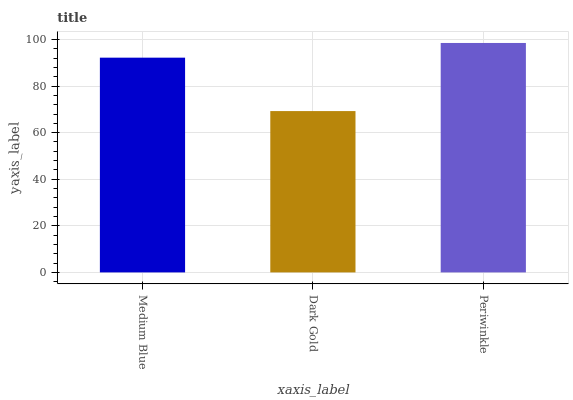Is Periwinkle the minimum?
Answer yes or no. No. Is Dark Gold the maximum?
Answer yes or no. No. Is Periwinkle greater than Dark Gold?
Answer yes or no. Yes. Is Dark Gold less than Periwinkle?
Answer yes or no. Yes. Is Dark Gold greater than Periwinkle?
Answer yes or no. No. Is Periwinkle less than Dark Gold?
Answer yes or no. No. Is Medium Blue the high median?
Answer yes or no. Yes. Is Medium Blue the low median?
Answer yes or no. Yes. Is Dark Gold the high median?
Answer yes or no. No. Is Periwinkle the low median?
Answer yes or no. No. 